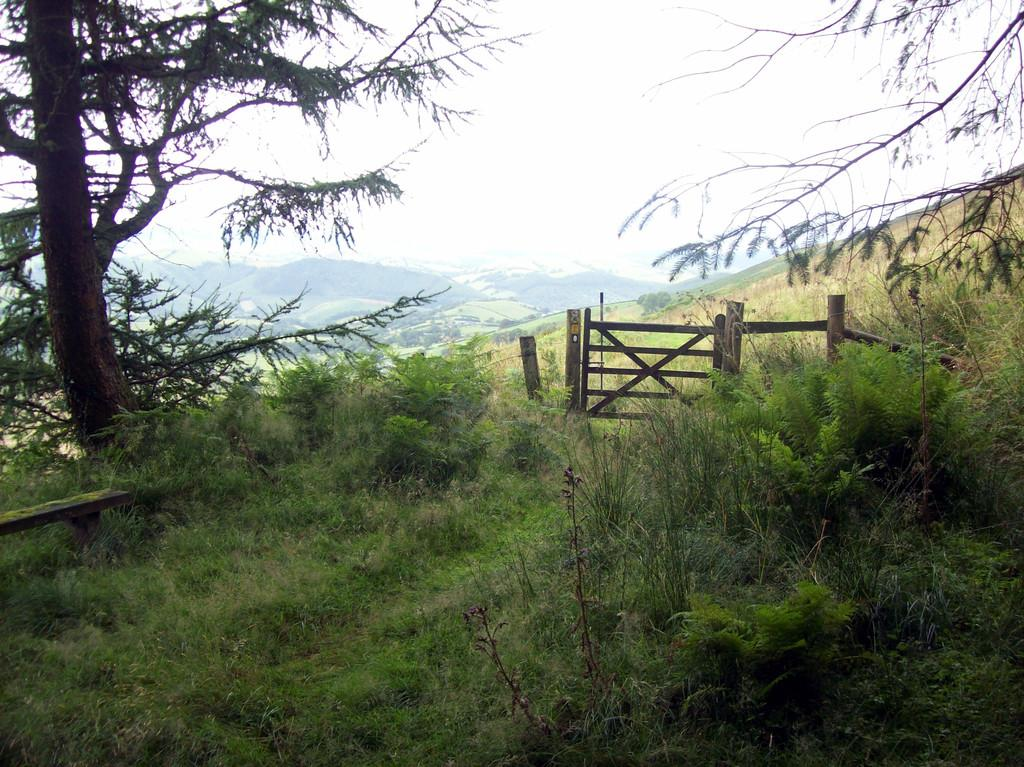What type of natural elements can be seen in the image? There are trees and plants visible in the image. What type of man-made structure is present in the image? There is a fencing in the image. What type of geographical feature can be seen in the distance? There are mountains visible in the image. What color is the crayon used to draw the mountains in the image? There is no crayon or drawing present in the image; it is a photograph of real mountains. 